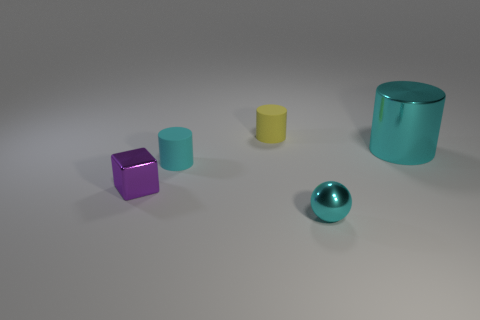Subtract all small cyan cylinders. How many cylinders are left? 2 Subtract 1 cubes. How many cubes are left? 0 Add 4 tiny metal blocks. How many objects exist? 9 Subtract all cyan cylinders. How many cylinders are left? 1 Add 5 large red matte balls. How many large red matte balls exist? 5 Subtract 1 purple blocks. How many objects are left? 4 Subtract all spheres. How many objects are left? 4 Subtract all yellow cylinders. Subtract all green cubes. How many cylinders are left? 2 Subtract all yellow blocks. How many yellow cylinders are left? 1 Subtract all cylinders. Subtract all big cylinders. How many objects are left? 1 